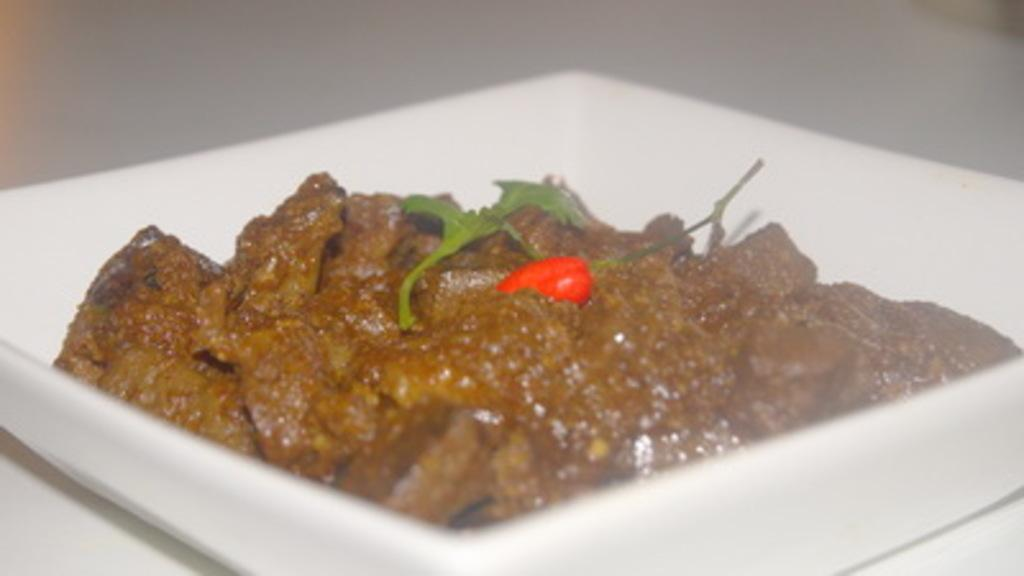Where was the image taken? The image is taken indoors. What piece of furniture is present in the image? There is a table in the image. What is placed on the table? There is a plate on the table. What is on the plate? There is a food item on the plate. What word is written on the notebook in the image? There is no notebook present in the image. How many bikes can be seen in the image? There are no bikes present in the image. 